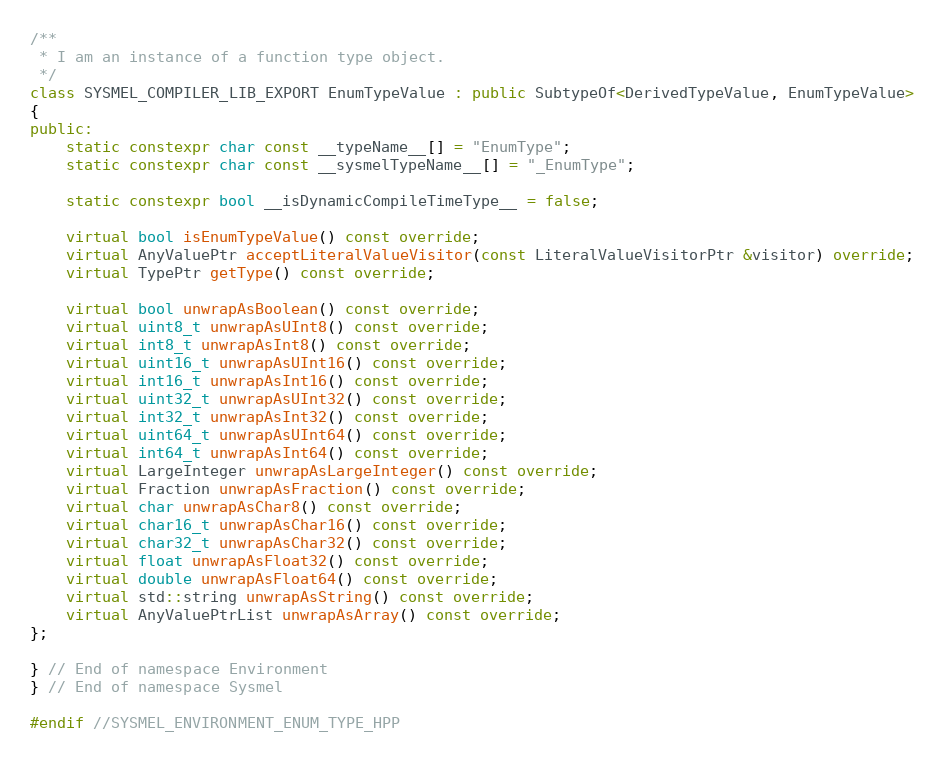Convert code to text. <code><loc_0><loc_0><loc_500><loc_500><_C++_>/**
 * I am an instance of a function type object.
 */
class SYSMEL_COMPILER_LIB_EXPORT EnumTypeValue : public SubtypeOf<DerivedTypeValue, EnumTypeValue>
{
public:
    static constexpr char const __typeName__[] = "EnumType";
    static constexpr char const __sysmelTypeName__[] = "_EnumType";

    static constexpr bool __isDynamicCompileTimeType__ = false;

    virtual bool isEnumTypeValue() const override;
    virtual AnyValuePtr acceptLiteralValueVisitor(const LiteralValueVisitorPtr &visitor) override;
    virtual TypePtr getType() const override;

    virtual bool unwrapAsBoolean() const override;
    virtual uint8_t unwrapAsUInt8() const override;
    virtual int8_t unwrapAsInt8() const override;
    virtual uint16_t unwrapAsUInt16() const override;
    virtual int16_t unwrapAsInt16() const override;
    virtual uint32_t unwrapAsUInt32() const override;
    virtual int32_t unwrapAsInt32() const override;
    virtual uint64_t unwrapAsUInt64() const override;
    virtual int64_t unwrapAsInt64() const override;
    virtual LargeInteger unwrapAsLargeInteger() const override;
    virtual Fraction unwrapAsFraction() const override;
    virtual char unwrapAsChar8() const override;
    virtual char16_t unwrapAsChar16() const override;
    virtual char32_t unwrapAsChar32() const override;
    virtual float unwrapAsFloat32() const override;
    virtual double unwrapAsFloat64() const override;
    virtual std::string unwrapAsString() const override;
    virtual AnyValuePtrList unwrapAsArray() const override;
};

} // End of namespace Environment
} // End of namespace Sysmel

#endif //SYSMEL_ENVIRONMENT_ENUM_TYPE_HPP</code> 